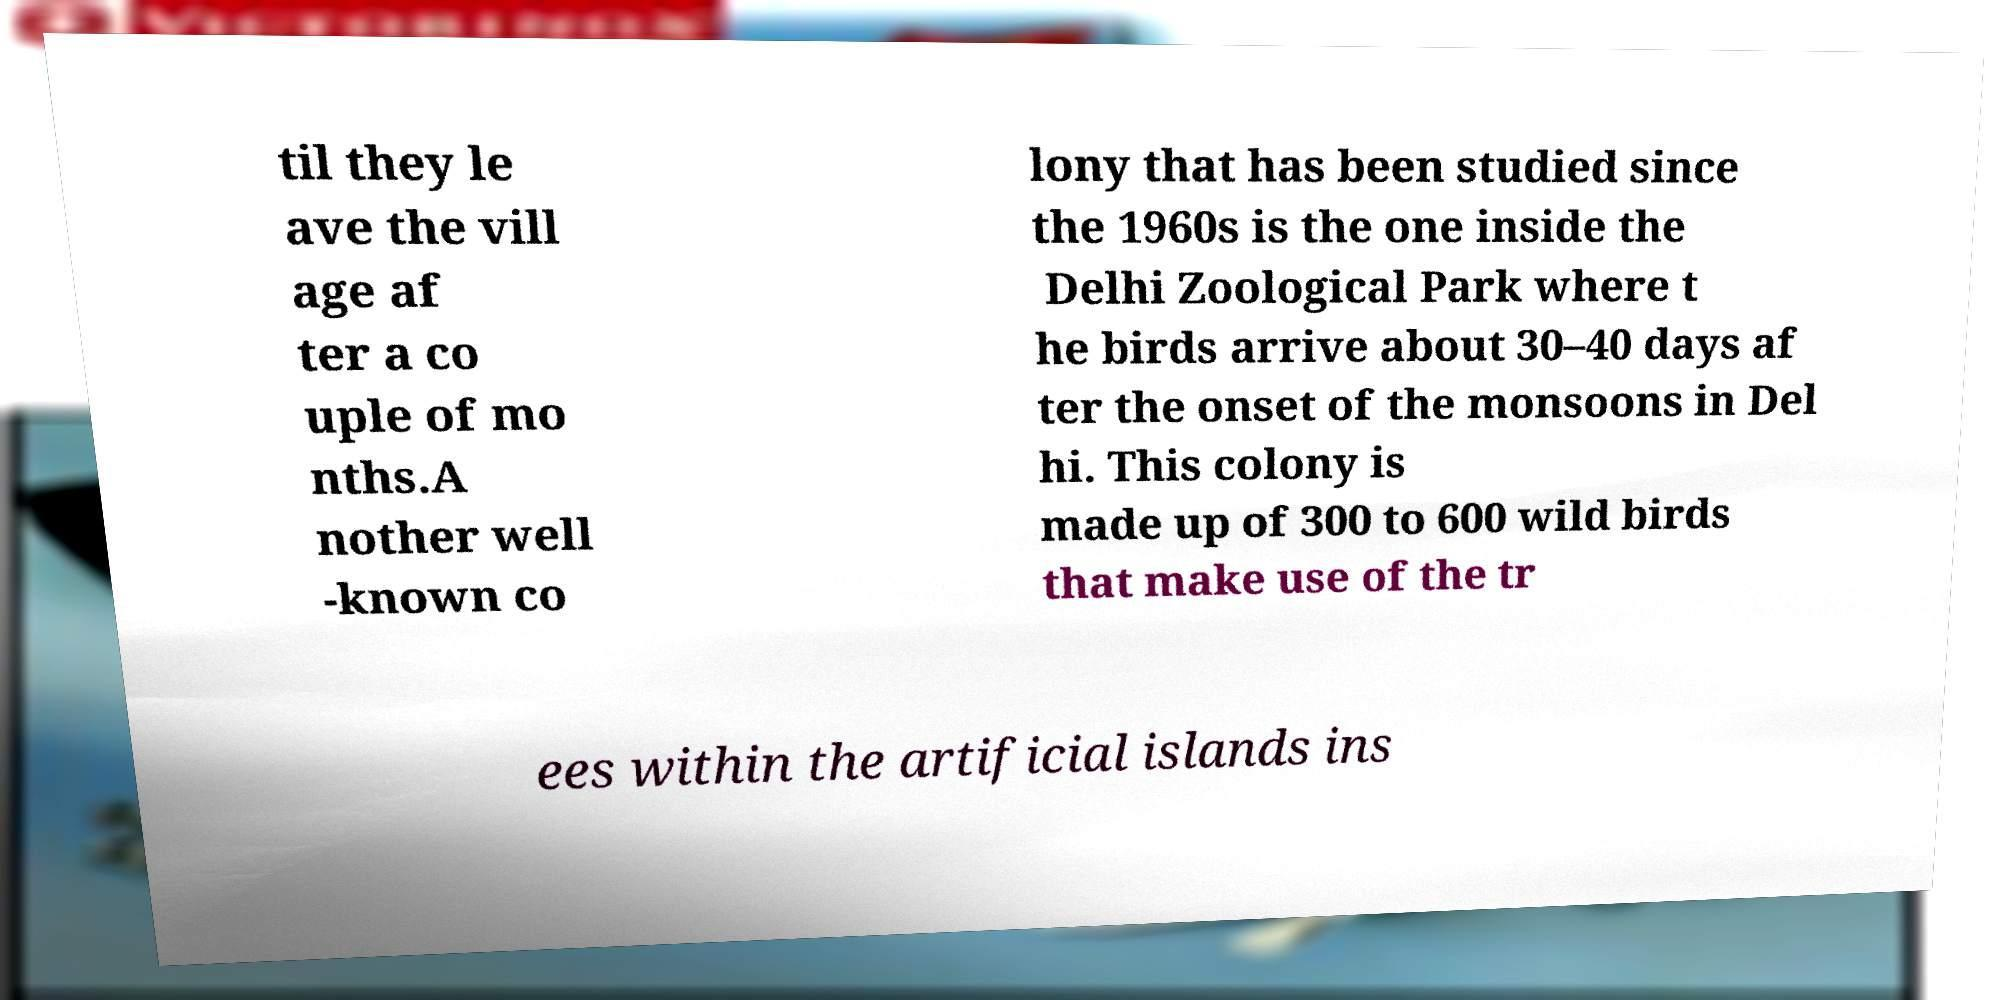What messages or text are displayed in this image? I need them in a readable, typed format. til they le ave the vill age af ter a co uple of mo nths.A nother well -known co lony that has been studied since the 1960s is the one inside the Delhi Zoological Park where t he birds arrive about 30–40 days af ter the onset of the monsoons in Del hi. This colony is made up of 300 to 600 wild birds that make use of the tr ees within the artificial islands ins 